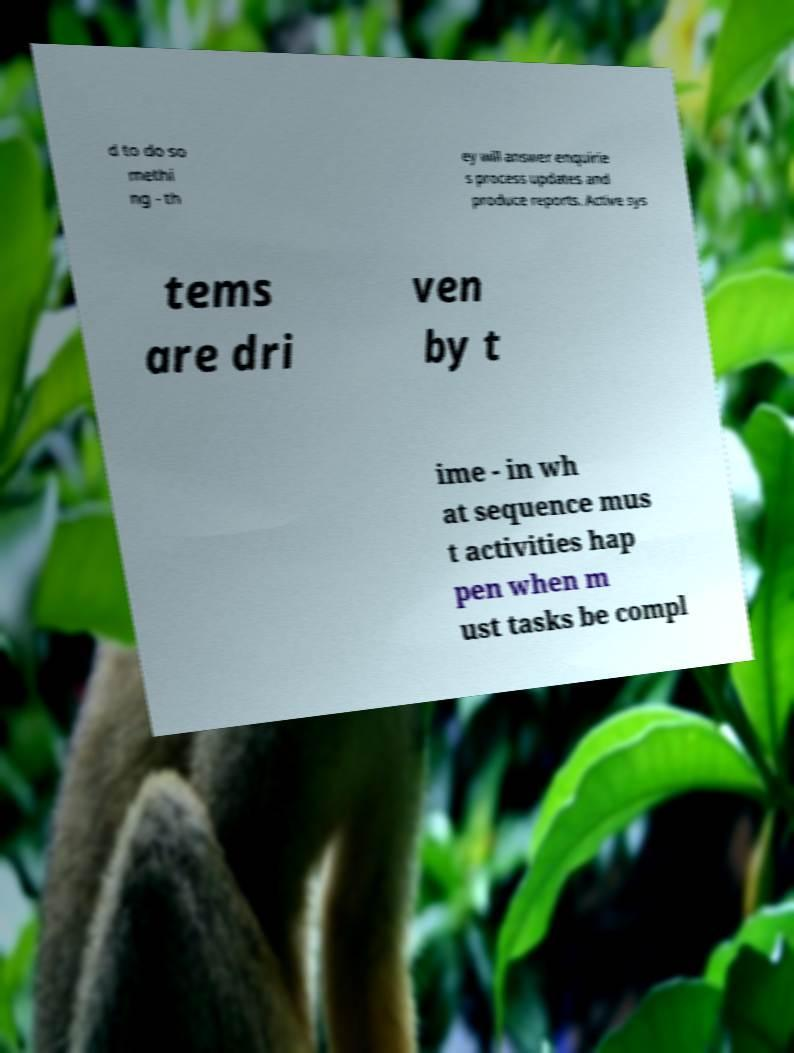Can you read and provide the text displayed in the image?This photo seems to have some interesting text. Can you extract and type it out for me? d to do so methi ng - th ey will answer enquirie s process updates and produce reports. Active sys tems are dri ven by t ime - in wh at sequence mus t activities hap pen when m ust tasks be compl 